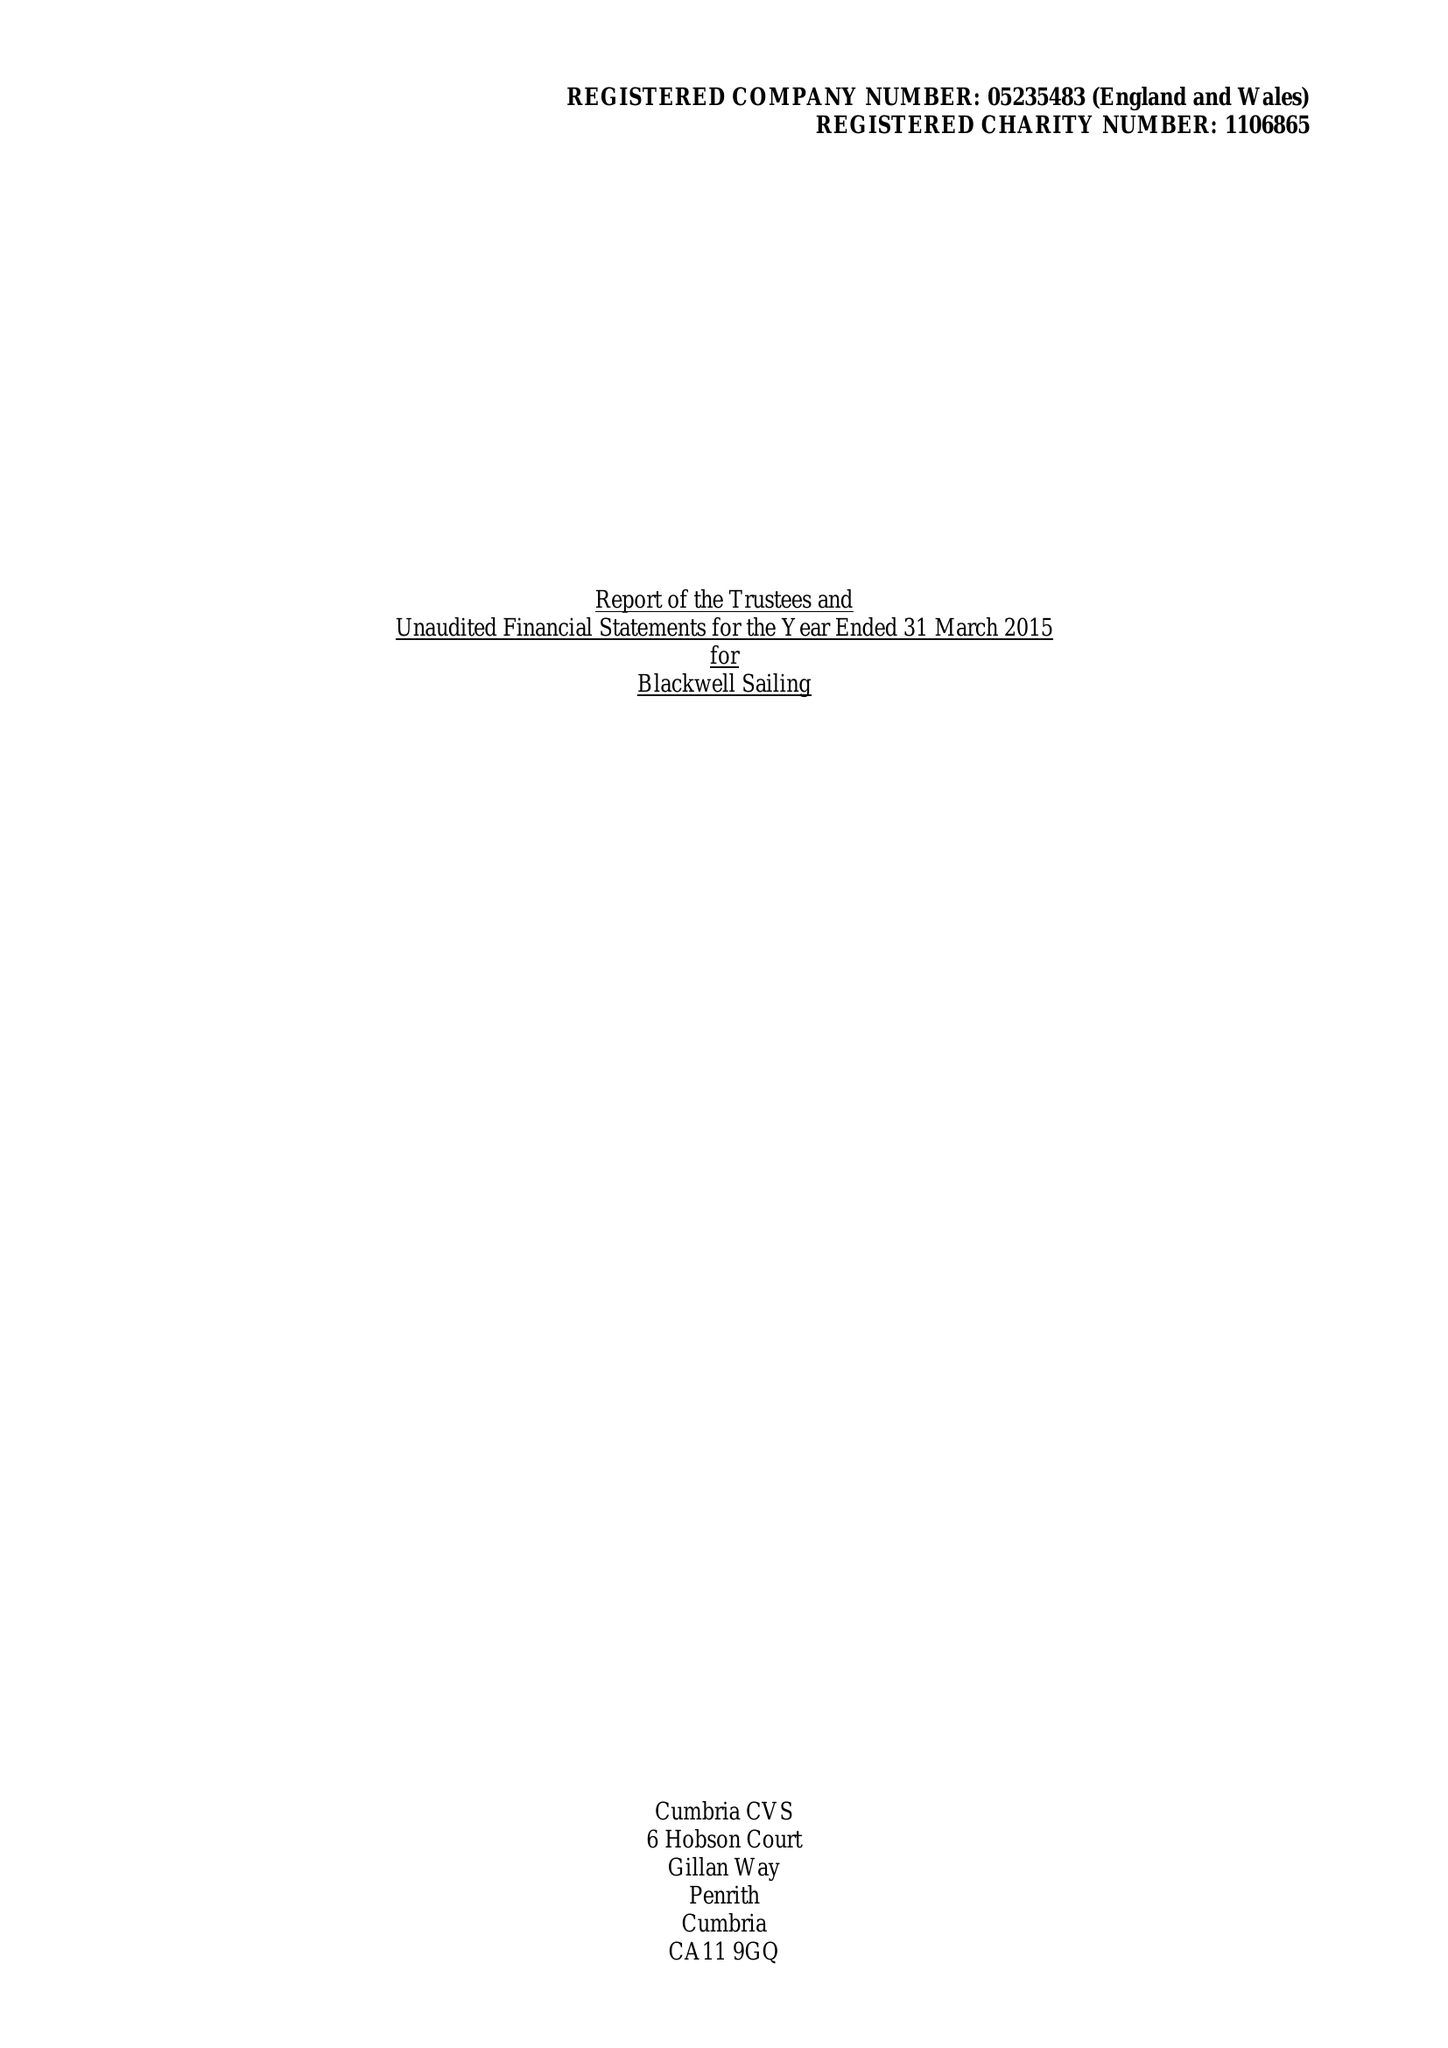What is the value for the address__post_town?
Answer the question using a single word or phrase. WINDERMERE 